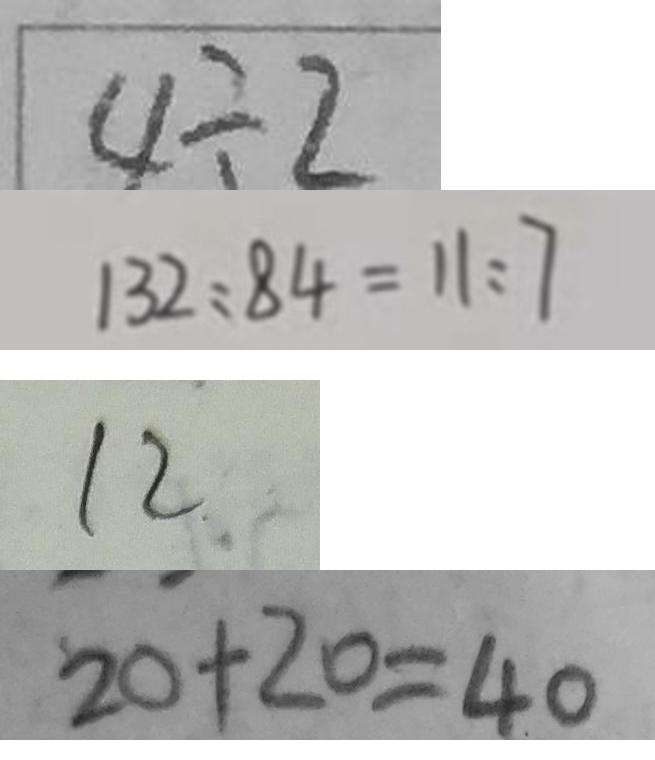<formula> <loc_0><loc_0><loc_500><loc_500>4 \div 2 
 1 3 2 : 8 4 = 1 1 : 7 
 1 2 
 2 0 + 2 0 = 4 0</formula> 